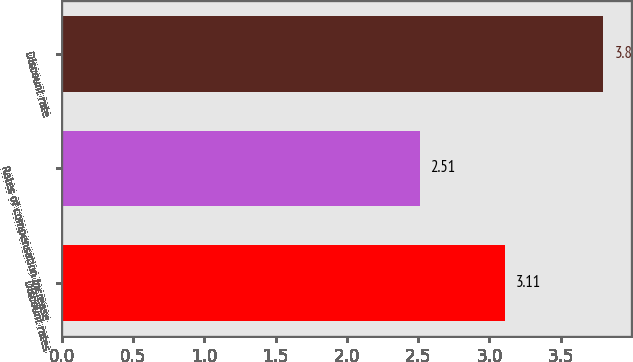Convert chart to OTSL. <chart><loc_0><loc_0><loc_500><loc_500><bar_chart><fcel>Discount rates<fcel>Rates of compensation increase<fcel>Discount rate<nl><fcel>3.11<fcel>2.51<fcel>3.8<nl></chart> 